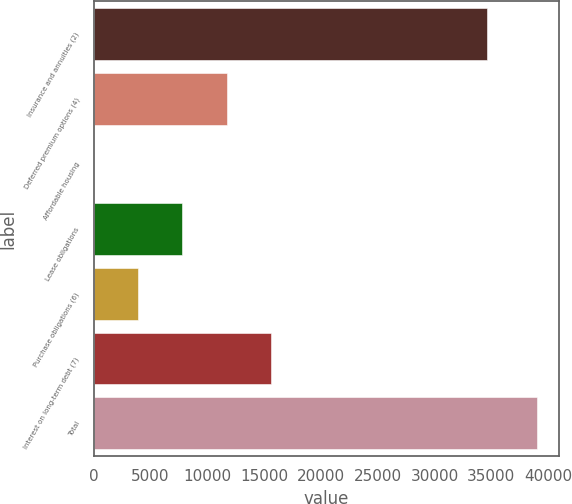<chart> <loc_0><loc_0><loc_500><loc_500><bar_chart><fcel>Insurance and annuities (2)<fcel>Deferred premium options (4)<fcel>Affordable housing<fcel>Lease obligations<fcel>Purchase obligations (6)<fcel>Interest on long-term debt (7)<fcel>Total<nl><fcel>34650<fcel>11706.2<fcel>2<fcel>7804.8<fcel>3903.4<fcel>15607.6<fcel>39016<nl></chart> 